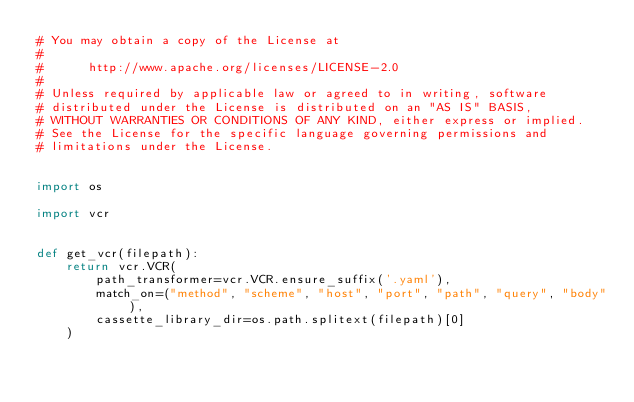Convert code to text. <code><loc_0><loc_0><loc_500><loc_500><_Python_># You may obtain a copy of the License at
# 
#      http://www.apache.org/licenses/LICENSE-2.0
# 
# Unless required by applicable law or agreed to in writing, software
# distributed under the License is distributed on an "AS IS" BASIS,
# WITHOUT WARRANTIES OR CONDITIONS OF ANY KIND, either express or implied.
# See the License for the specific language governing permissions and
# limitations under the License.


import os

import vcr


def get_vcr(filepath):
    return vcr.VCR(
        path_transformer=vcr.VCR.ensure_suffix('.yaml'),
        match_on=("method", "scheme", "host", "port", "path", "query", "body"),
        cassette_library_dir=os.path.splitext(filepath)[0]
    )
</code> 